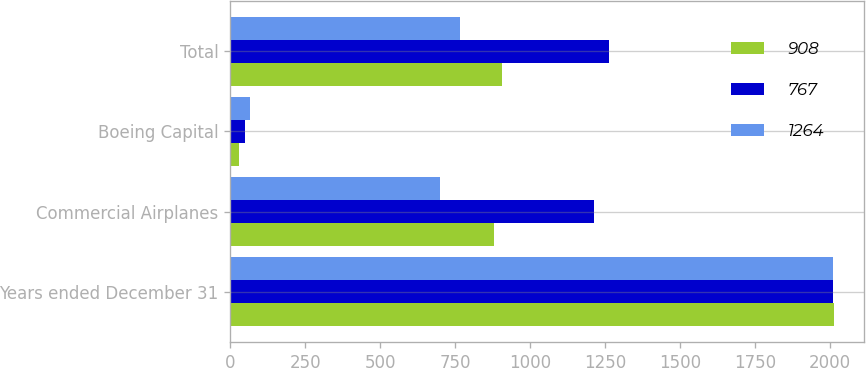Convert chart to OTSL. <chart><loc_0><loc_0><loc_500><loc_500><stacked_bar_chart><ecel><fcel>Years ended December 31<fcel>Commercial Airplanes<fcel>Boeing Capital<fcel>Total<nl><fcel>908<fcel>2013<fcel>879<fcel>29<fcel>908<nl><fcel>767<fcel>2012<fcel>1215<fcel>49<fcel>1264<nl><fcel>1264<fcel>2011<fcel>701<fcel>66<fcel>767<nl></chart> 